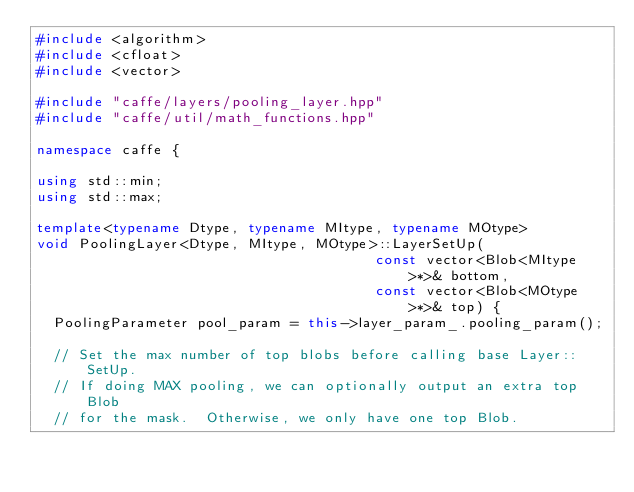Convert code to text. <code><loc_0><loc_0><loc_500><loc_500><_C++_>#include <algorithm>
#include <cfloat>
#include <vector>

#include "caffe/layers/pooling_layer.hpp"
#include "caffe/util/math_functions.hpp"

namespace caffe {

using std::min;
using std::max;

template<typename Dtype, typename MItype, typename MOtype>
void PoolingLayer<Dtype, MItype, MOtype>::LayerSetUp(
                                        const vector<Blob<MItype>*>& bottom,
                                        const vector<Blob<MOtype>*>& top) {
  PoolingParameter pool_param = this->layer_param_.pooling_param();

  // Set the max number of top blobs before calling base Layer::SetUp.
  // If doing MAX pooling, we can optionally output an extra top Blob
  // for the mask.  Otherwise, we only have one top Blob.</code> 